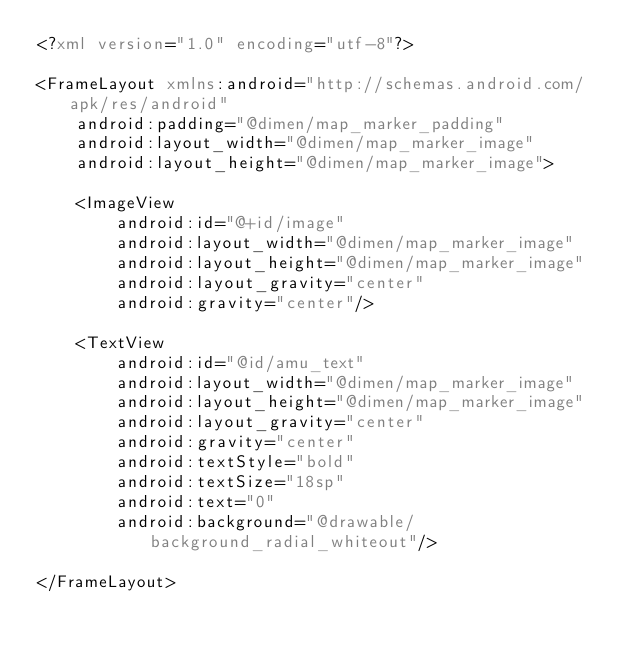<code> <loc_0><loc_0><loc_500><loc_500><_XML_><?xml version="1.0" encoding="utf-8"?>

<FrameLayout xmlns:android="http://schemas.android.com/apk/res/android"
    android:padding="@dimen/map_marker_padding"
    android:layout_width="@dimen/map_marker_image"
    android:layout_height="@dimen/map_marker_image">

    <ImageView
        android:id="@+id/image"
        android:layout_width="@dimen/map_marker_image"
        android:layout_height="@dimen/map_marker_image"
        android:layout_gravity="center"
        android:gravity="center"/>

    <TextView
        android:id="@id/amu_text"
        android:layout_width="@dimen/map_marker_image"
        android:layout_height="@dimen/map_marker_image"
        android:layout_gravity="center"
        android:gravity="center"
        android:textStyle="bold"
        android:textSize="18sp"
        android:text="0"
        android:background="@drawable/background_radial_whiteout"/>

</FrameLayout></code> 